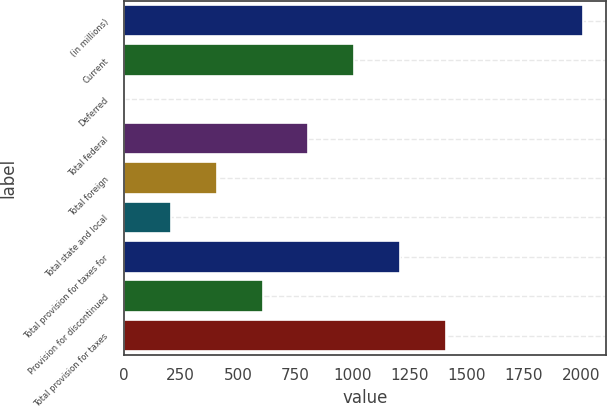Convert chart. <chart><loc_0><loc_0><loc_500><loc_500><bar_chart><fcel>(in millions)<fcel>Current<fcel>Deferred<fcel>Total federal<fcel>Total foreign<fcel>Total state and local<fcel>Total provision for taxes for<fcel>Provision for discontinued<fcel>Total provision for taxes<nl><fcel>2011<fcel>1008.5<fcel>6<fcel>808<fcel>407<fcel>206.5<fcel>1209<fcel>607.5<fcel>1409.5<nl></chart> 